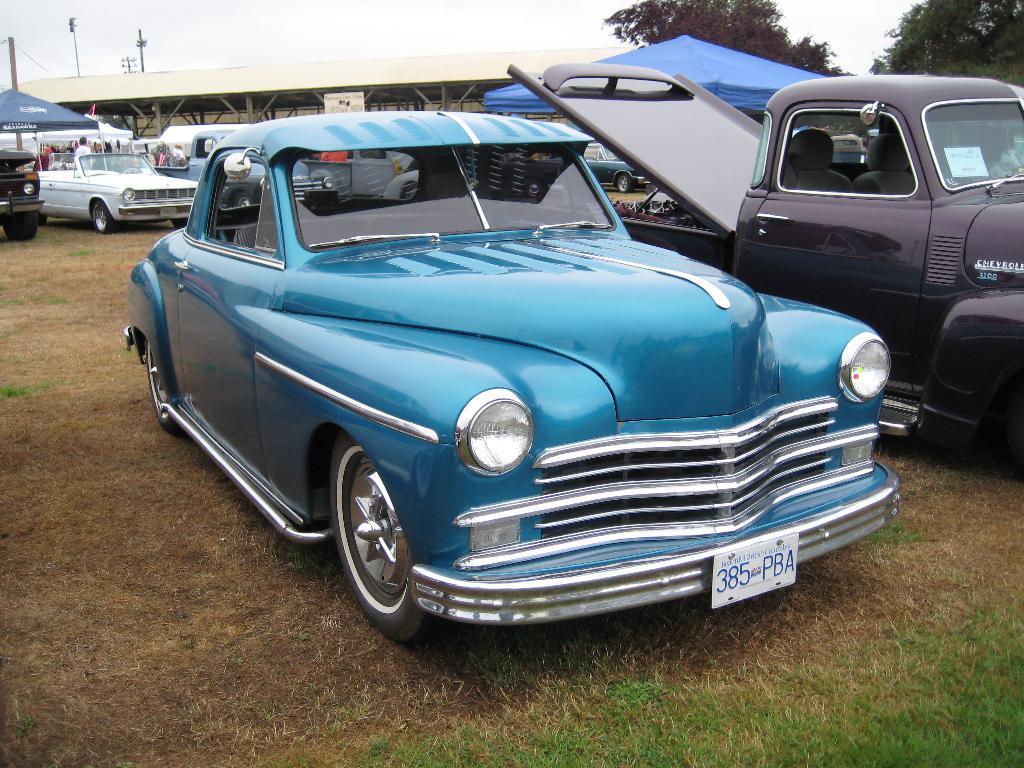How would you summarize this image in a sentence or two? In the middle of the image we can see some vehicles. Behind the vehicles few people are standing and there are some tents and trees and poles and sky. At the bottom of the image there is grass. 